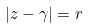<formula> <loc_0><loc_0><loc_500><loc_500>| z - \gamma | = r</formula> 